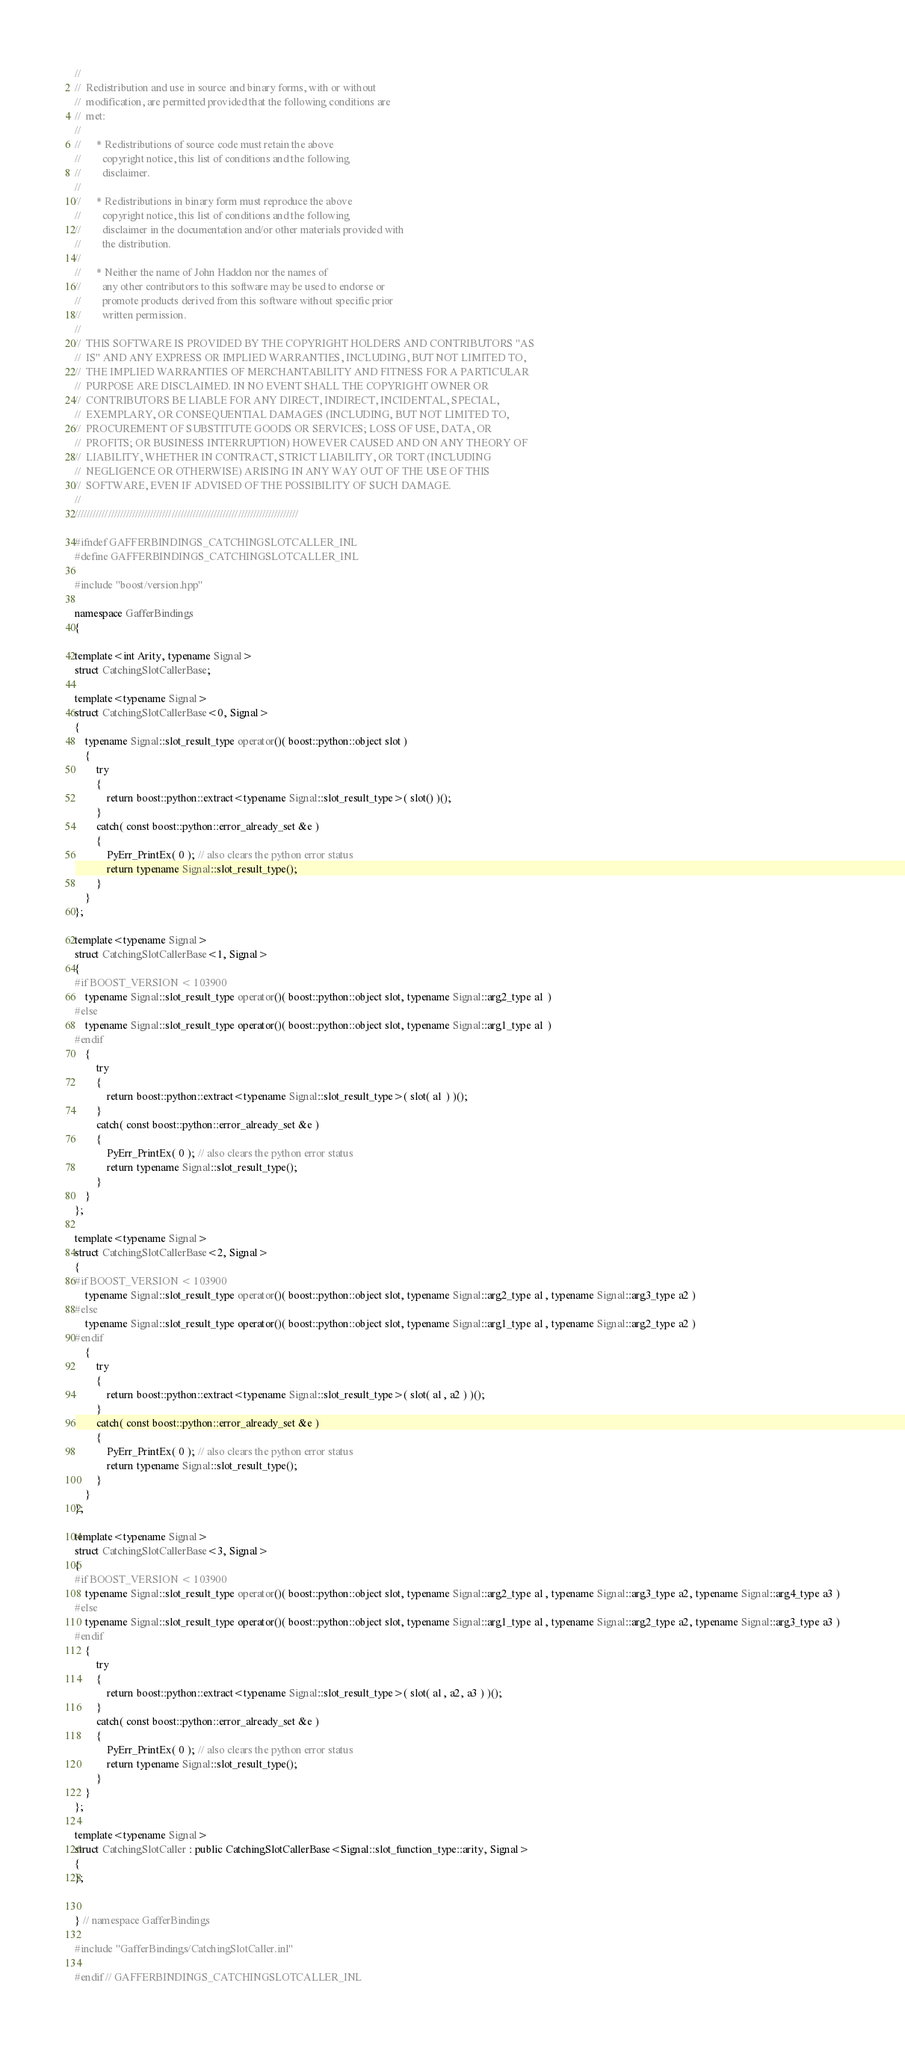<code> <loc_0><loc_0><loc_500><loc_500><_C++_>//  
//  Redistribution and use in source and binary forms, with or without
//  modification, are permitted provided that the following conditions are
//  met:
//  
//      * Redistributions of source code must retain the above
//        copyright notice, this list of conditions and the following
//        disclaimer.
//  
//      * Redistributions in binary form must reproduce the above
//        copyright notice, this list of conditions and the following
//        disclaimer in the documentation and/or other materials provided with
//        the distribution.
//  
//      * Neither the name of John Haddon nor the names of
//        any other contributors to this software may be used to endorse or
//        promote products derived from this software without specific prior
//        written permission.
//  
//  THIS SOFTWARE IS PROVIDED BY THE COPYRIGHT HOLDERS AND CONTRIBUTORS "AS
//  IS" AND ANY EXPRESS OR IMPLIED WARRANTIES, INCLUDING, BUT NOT LIMITED TO,
//  THE IMPLIED WARRANTIES OF MERCHANTABILITY AND FITNESS FOR A PARTICULAR
//  PURPOSE ARE DISCLAIMED. IN NO EVENT SHALL THE COPYRIGHT OWNER OR
//  CONTRIBUTORS BE LIABLE FOR ANY DIRECT, INDIRECT, INCIDENTAL, SPECIAL,
//  EXEMPLARY, OR CONSEQUENTIAL DAMAGES (INCLUDING, BUT NOT LIMITED TO,
//  PROCUREMENT OF SUBSTITUTE GOODS OR SERVICES; LOSS OF USE, DATA, OR
//  PROFITS; OR BUSINESS INTERRUPTION) HOWEVER CAUSED AND ON ANY THEORY OF
//  LIABILITY, WHETHER IN CONTRACT, STRICT LIABILITY, OR TORT (INCLUDING
//  NEGLIGENCE OR OTHERWISE) ARISING IN ANY WAY OUT OF THE USE OF THIS
//  SOFTWARE, EVEN IF ADVISED OF THE POSSIBILITY OF SUCH DAMAGE.
//  
//////////////////////////////////////////////////////////////////////////

#ifndef GAFFERBINDINGS_CATCHINGSLOTCALLER_INL
#define GAFFERBINDINGS_CATCHINGSLOTCALLER_INL

#include "boost/version.hpp"

namespace GafferBindings
{

template<int Arity, typename Signal>
struct CatchingSlotCallerBase;

template<typename Signal>
struct CatchingSlotCallerBase<0, Signal>
{
	typename Signal::slot_result_type operator()( boost::python::object slot )
	{
		try
		{
			return boost::python::extract<typename Signal::slot_result_type>( slot() )();
		}
		catch( const boost::python::error_already_set &e )
		{
			PyErr_PrintEx( 0 ); // also clears the python error status
			return typename Signal::slot_result_type();
		}
	}
};

template<typename Signal>
struct CatchingSlotCallerBase<1, Signal>
{
#if BOOST_VERSION < 103900
	typename Signal::slot_result_type operator()( boost::python::object slot, typename Signal::arg2_type a1 )
#else
	typename Signal::slot_result_type operator()( boost::python::object slot, typename Signal::arg1_type a1 )
#endif
	{
		try
		{
			return boost::python::extract<typename Signal::slot_result_type>( slot( a1 ) )();
		}
		catch( const boost::python::error_already_set &e )
		{
			PyErr_PrintEx( 0 ); // also clears the python error status
			return typename Signal::slot_result_type();
		}
	}
};

template<typename Signal>
struct CatchingSlotCallerBase<2, Signal>
{
#if BOOST_VERSION < 103900
	typename Signal::slot_result_type operator()( boost::python::object slot, typename Signal::arg2_type a1, typename Signal::arg3_type a2 )
#else
	typename Signal::slot_result_type operator()( boost::python::object slot, typename Signal::arg1_type a1, typename Signal::arg2_type a2 )
#endif
	{
		try
		{
			return boost::python::extract<typename Signal::slot_result_type>( slot( a1, a2 ) )();
		}
		catch( const boost::python::error_already_set &e )
		{
			PyErr_PrintEx( 0 ); // also clears the python error status
			return typename Signal::slot_result_type();
		}
	}
};

template<typename Signal>
struct CatchingSlotCallerBase<3, Signal>
{
#if BOOST_VERSION < 103900
	typename Signal::slot_result_type operator()( boost::python::object slot, typename Signal::arg2_type a1, typename Signal::arg3_type a2, typename Signal::arg4_type a3 )
#else
	typename Signal::slot_result_type operator()( boost::python::object slot, typename Signal::arg1_type a1, typename Signal::arg2_type a2, typename Signal::arg3_type a3 )
#endif
	{
		try
		{
			return boost::python::extract<typename Signal::slot_result_type>( slot( a1, a2, a3 ) )();
		}
		catch( const boost::python::error_already_set &e )
		{
			PyErr_PrintEx( 0 ); // also clears the python error status
			return typename Signal::slot_result_type();
		}
	}
};

template<typename Signal>
struct CatchingSlotCaller : public CatchingSlotCallerBase<Signal::slot_function_type::arity, Signal>
{
};


} // namespace GafferBindings

#include "GafferBindings/CatchingSlotCaller.inl"

#endif // GAFFERBINDINGS_CATCHINGSLOTCALLER_INL

</code> 